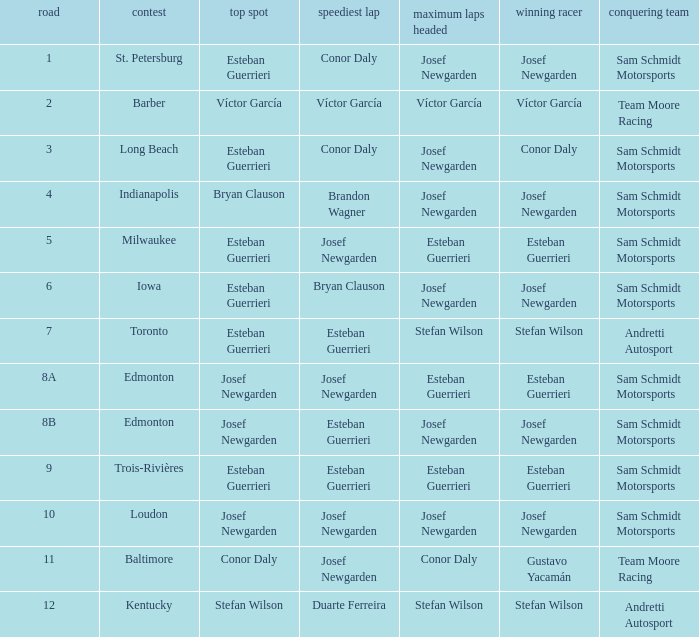What race did josef newgarden have the fastest lap and lead the most laps? Loudon. 